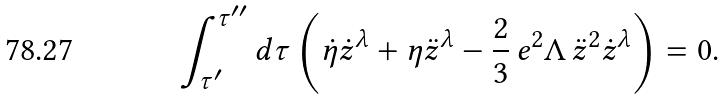Convert formula to latex. <formula><loc_0><loc_0><loc_500><loc_500>\int _ { { \tau } ^ { \prime } } ^ { { \tau } ^ { \prime \prime } } d \tau \left ( { \dot { \eta } } { \dot { z } } ^ { \lambda } + { \eta } { \ddot { z } } ^ { \lambda } - \frac { 2 } { 3 } \, e ^ { 2 } \Lambda \, { \ddot { z } } ^ { 2 } { \dot { z } } ^ { \lambda } \right ) = 0 .</formula> 